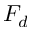Convert formula to latex. <formula><loc_0><loc_0><loc_500><loc_500>F _ { d }</formula> 